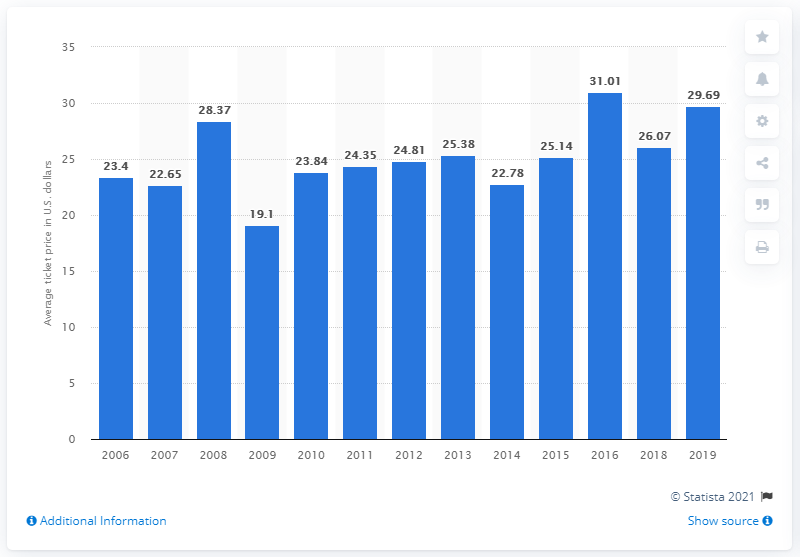Highlight a few significant elements in this photo. The average ticket price for Toronto Blue Jays games in 2019 was $29.69. 